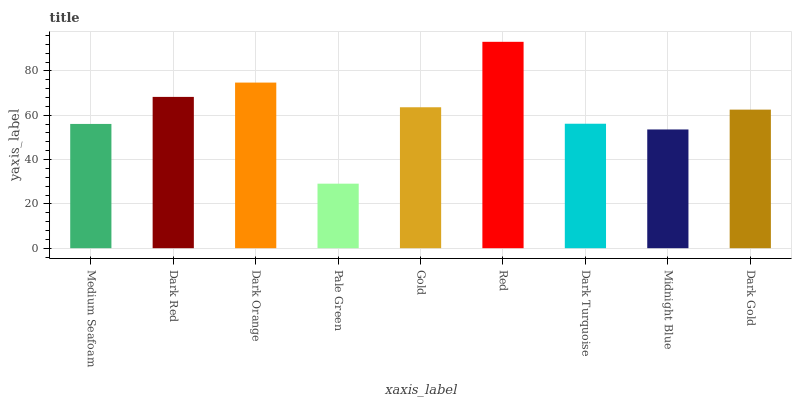Is Pale Green the minimum?
Answer yes or no. Yes. Is Red the maximum?
Answer yes or no. Yes. Is Dark Red the minimum?
Answer yes or no. No. Is Dark Red the maximum?
Answer yes or no. No. Is Dark Red greater than Medium Seafoam?
Answer yes or no. Yes. Is Medium Seafoam less than Dark Red?
Answer yes or no. Yes. Is Medium Seafoam greater than Dark Red?
Answer yes or no. No. Is Dark Red less than Medium Seafoam?
Answer yes or no. No. Is Dark Gold the high median?
Answer yes or no. Yes. Is Dark Gold the low median?
Answer yes or no. Yes. Is Red the high median?
Answer yes or no. No. Is Midnight Blue the low median?
Answer yes or no. No. 